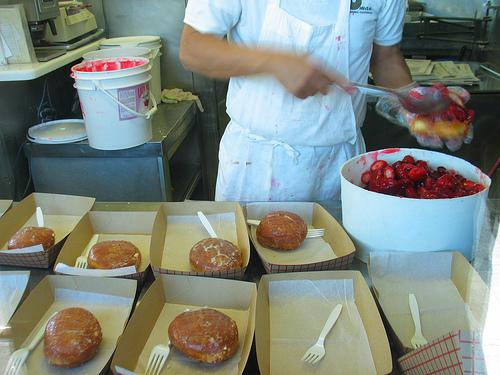Count the number of brown food trays and describe their content. There are four brown food trays, each containing a donut and a fork. Describe the clothing of the person in the image. The man is wearing a white shirt with an emblem on the chest and a white apron. Identify the primary sentiment conveyed in this image. The primary sentiment conveyed is a sense of preparation and focus while making strawberry donuts. Mention the type of spoon and its unique features present in the image. There is a metal spoon placing strawberries and a white spoon with 4 prongs. What type of pastry can be found in a brown cardboard tray? A glazed donut can be found in the brown cardboard tray. Perform a basic assessment of the image quality. The image quality is quite detailed, with objects being easily distinguishable and clear. Analyze the interaction between the man and the spoon in the image. The man is holding the large silver spoon carefully to cover it with strawberries. What is the configuration of the three white buckets? The three white buckets are arranged in a line. Can you tell what the person in the image is doing? The man is making strawberry donuts while wearing a plastic glove on his right hand and holding a silver spoon. Please provide a brief description of the white bucket filled with strawberries. The white bucket is filled with red strawberries and has a handle. 